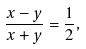Convert formula to latex. <formula><loc_0><loc_0><loc_500><loc_500>\frac { x - y } { x + y } = \frac { 1 } { 2 } ,</formula> 